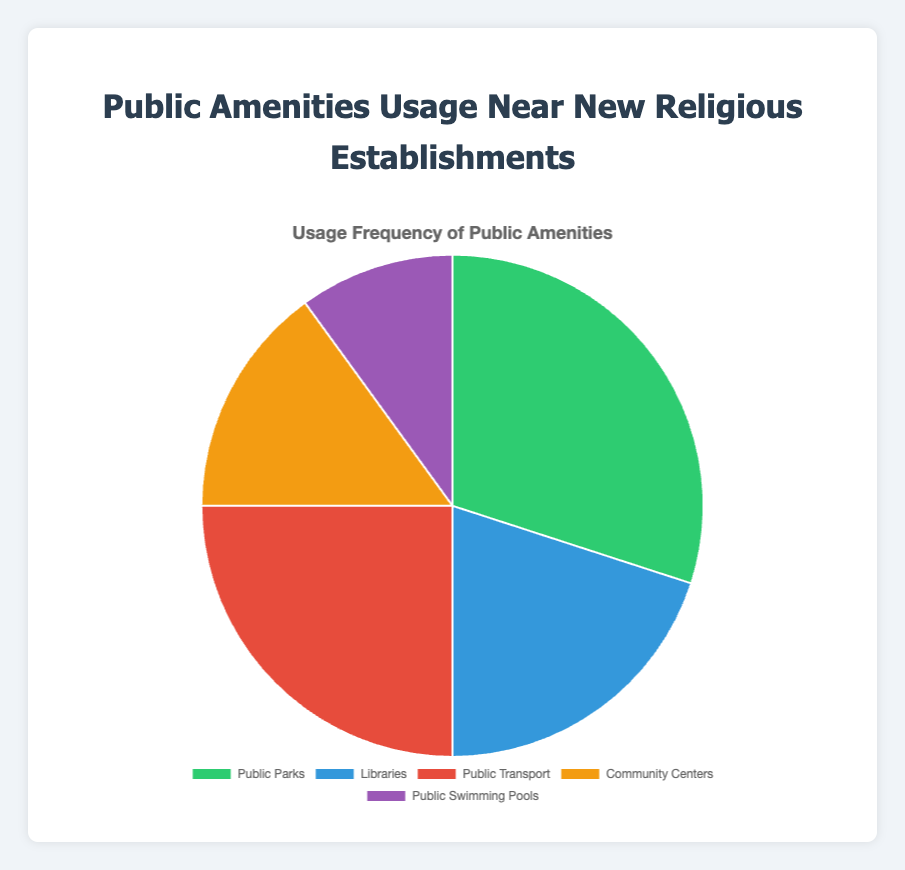What's the most frequently used public amenity near new religious establishments? According to the pie chart, the largest segment represents 'Public Parks', which has the highest usage percentage of 30%. This indicates that 'Public Parks' is the most frequently used public amenity near new religious establishments.
Answer: Public Parks Which public amenity has the lowest usage percentage? The smallest segment in the pie chart corresponds to 'Public Swimming Pools', which has a usage percentage of 10%. Therefore, 'Public Swimming Pools' has the lowest usage percentage.
Answer: Public Swimming Pools What is the total usage percentage for Libraries and Community Centers combined? To find the total usage percentage for Libraries and Community Centers, we sum their individual percentages: Libraries (20%) + Community Centers (15%) = 35%.
Answer: 35% Compare the usage percentages of Public Parks and Public Transport. Which one is higher and by how much? Public Parks have a usage percentage of 30%, while Public Transport has a usage percentage of 25%. To find the difference, we subtract the smaller percentage from the larger one: 30% - 25% = 5%. Public Parks have a higher usage percentage by 5%.
Answer: Public Parks by 5% What is the average usage percentage of all the public amenities? To find the average usage percentage, we sum all the percentages and divide by the number of amenities. (30% + 20% + 25% + 15% + 10%) / 5 = 100% / 5 = 20%.
Answer: 20% What is the combined usage percentage of Public Parks, Libraries, and Public Transport? To find the combined usage percentage of Public Parks, Libraries, and Public Transport, we sum their individual percentages: Public Parks (30%) + Libraries (20%) + Public Transport (25%) = 75%.
Answer: 75% If Public Parks and Libraries were merged into one category, what would be its new percentage, and would it be the highest? By merging Public Parks (30%) and Libraries (20%), the new category would have a usage percentage of 30% + 20% = 50%. This would indeed be the highest percentage, surpassing the current highest individual percentage of 30% for Public Parks.
Answer: 50%, yes Which amenities have usage percentages that fall below the average usage percentage of 20%? The public amenities with usage percentages below the average (20%) are Community Centers (15%) and Public Swimming Pools (10%).
Answer: Community Centers and Public Swimming Pools 